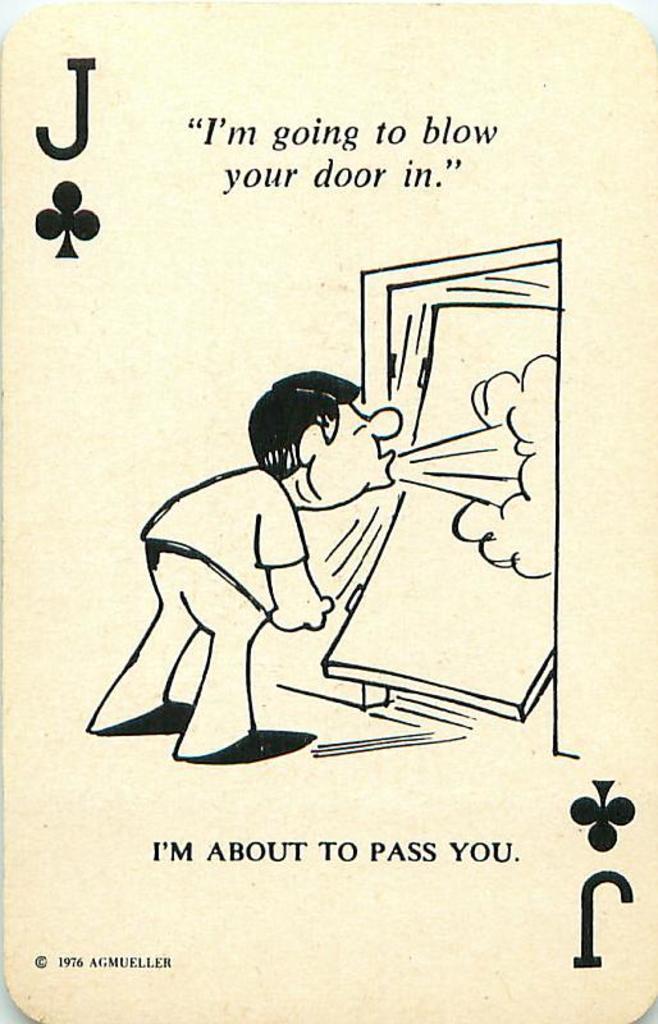Please provide a concise description of this image. In this image, we can see a card contains depiction of a person and some text. 